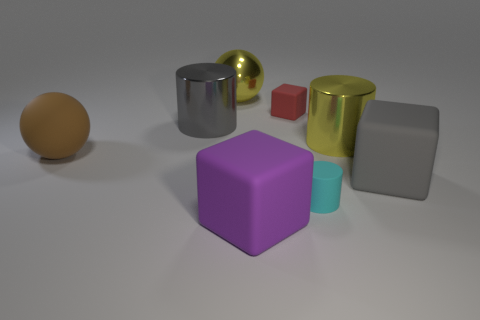Which objects in the image seem the most similar in terms of shape? The large gray block and the gold-colored block share a similar cuboid shape, distinguished mainly by their size and color. The small red cube also shares this cuboid geometry but on a smaller scale. Are there any objects that differ significantly from the rest in terms of color? Yes, the gold-colored sphere stands out with its vibrant, reflective hue, contrasting markedly with the more subdued colors of the other objects in the scene. 